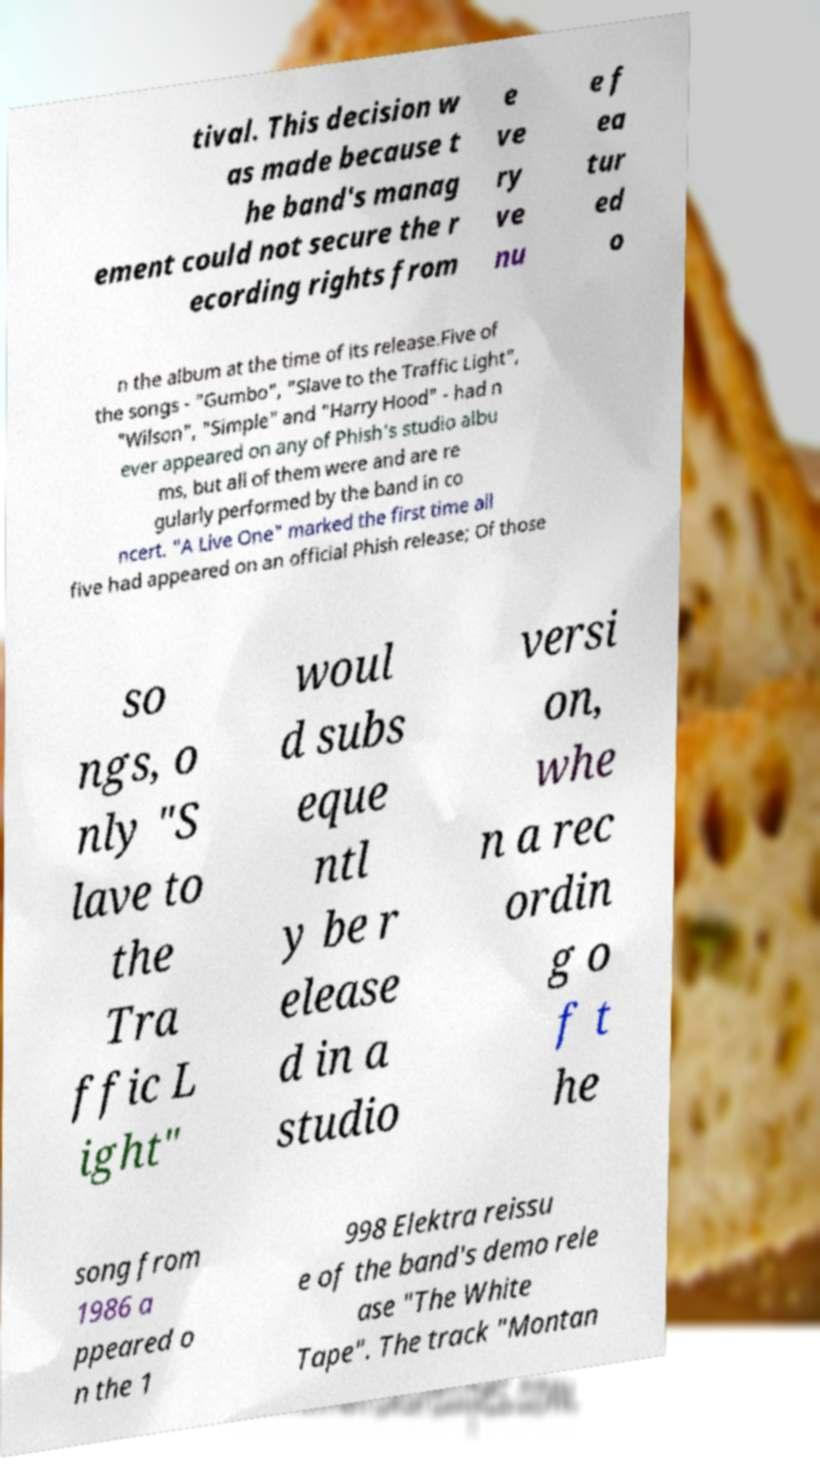Can you read and provide the text displayed in the image?This photo seems to have some interesting text. Can you extract and type it out for me? tival. This decision w as made because t he band's manag ement could not secure the r ecording rights from e ve ry ve nu e f ea tur ed o n the album at the time of its release.Five of the songs - "Gumbo", "Slave to the Traffic Light", "Wilson", "Simple" and "Harry Hood" - had n ever appeared on any of Phish's studio albu ms, but all of them were and are re gularly performed by the band in co ncert. "A Live One" marked the first time all five had appeared on an official Phish release; Of those so ngs, o nly "S lave to the Tra ffic L ight" woul d subs eque ntl y be r elease d in a studio versi on, whe n a rec ordin g o f t he song from 1986 a ppeared o n the 1 998 Elektra reissu e of the band's demo rele ase "The White Tape". The track "Montan 